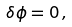<formula> <loc_0><loc_0><loc_500><loc_500>\delta \phi = 0 \, ,</formula> 